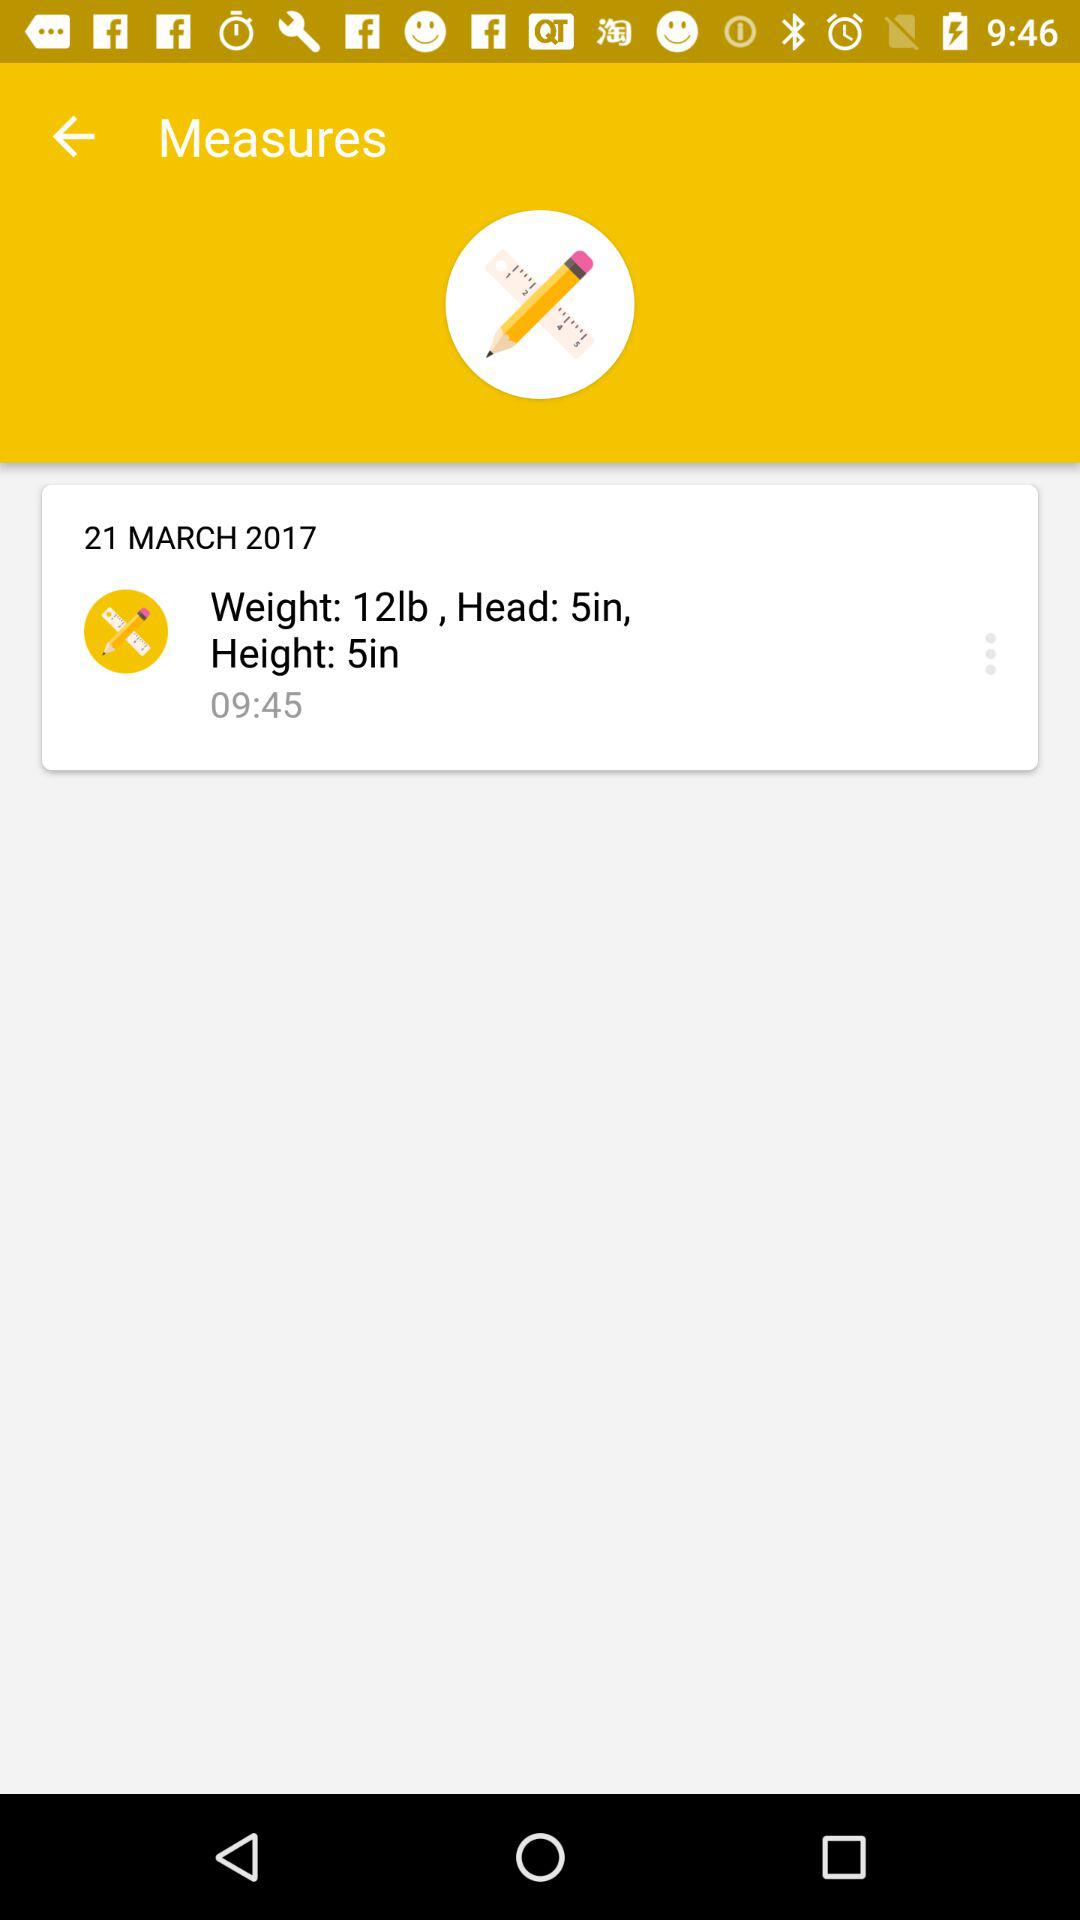What is the date of the measurements? The date of the measurements is March 21, 2017. 